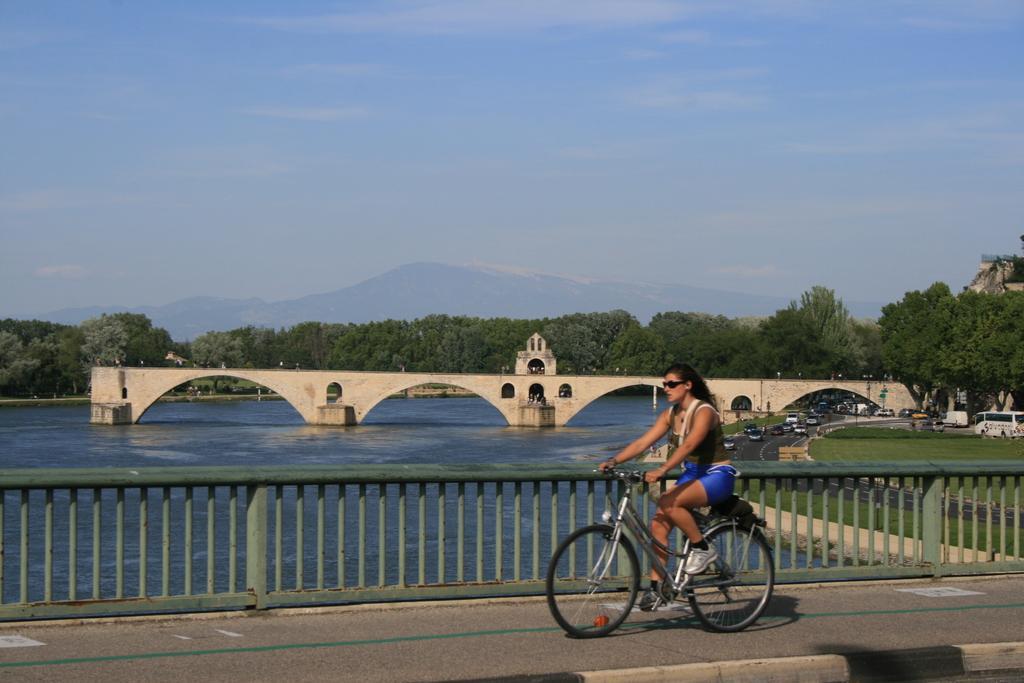In one or two sentences, can you explain what this image depicts? Far there are number of trees and mountains. This is a freshwater river. This is bridge. Vehicles on road. This woman is riding a bicycle. This is fence. 